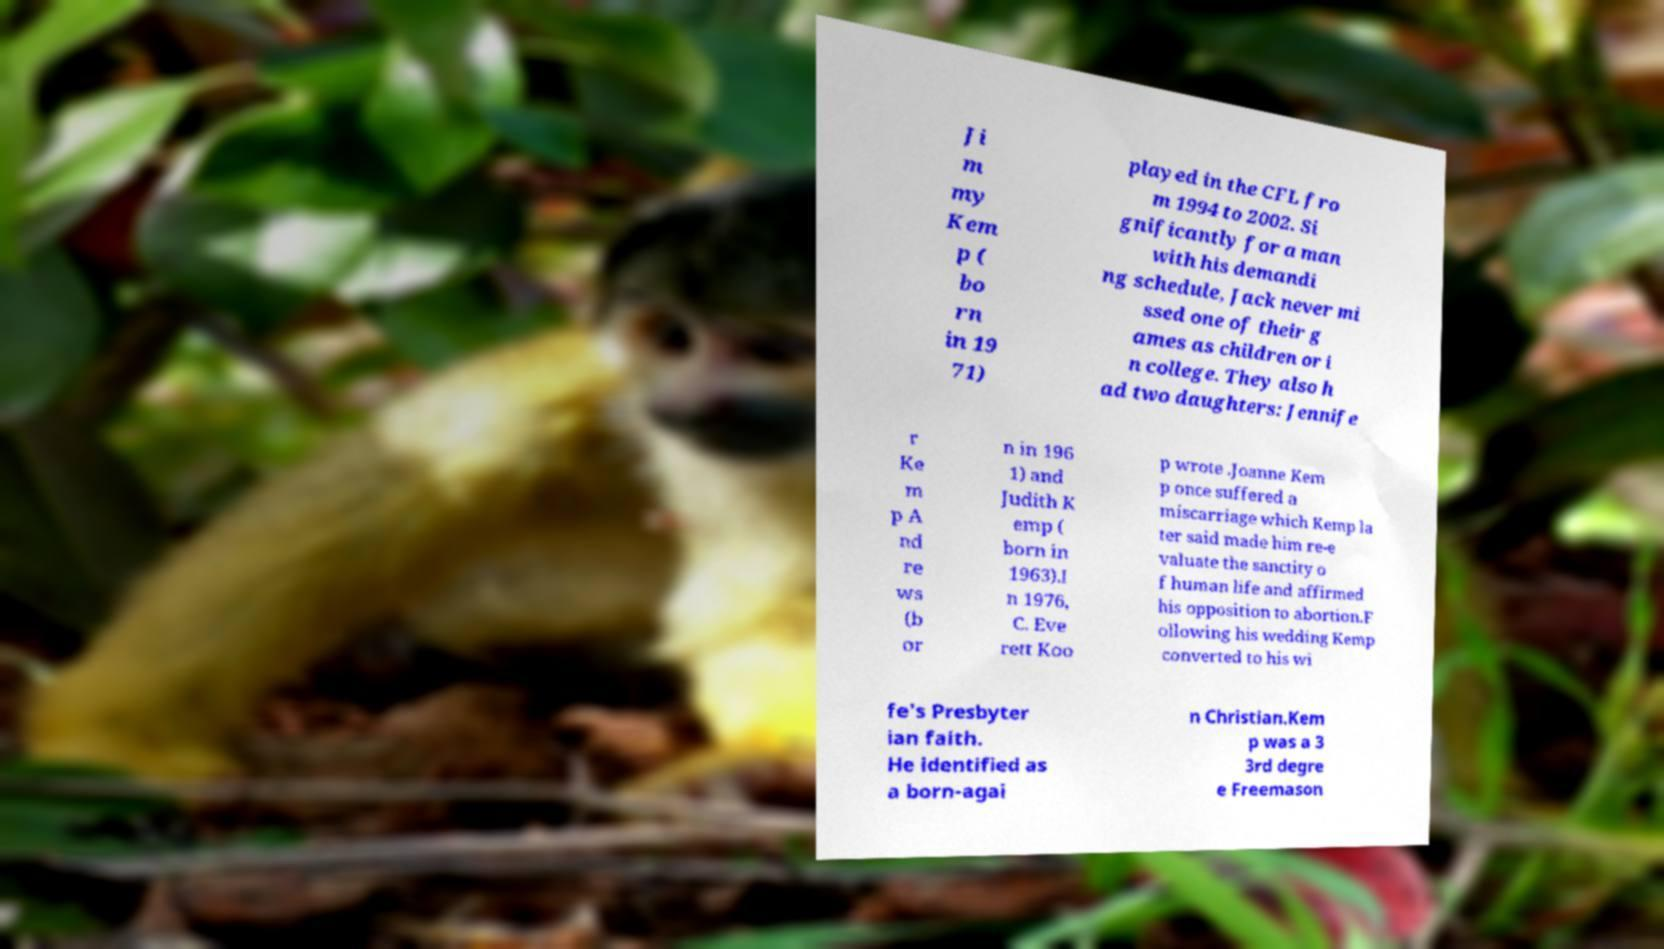Please identify and transcribe the text found in this image. Ji m my Kem p ( bo rn in 19 71) played in the CFL fro m 1994 to 2002. Si gnificantly for a man with his demandi ng schedule, Jack never mi ssed one of their g ames as children or i n college. They also h ad two daughters: Jennife r Ke m p A nd re ws (b or n in 196 1) and Judith K emp ( born in 1963).I n 1976, C. Eve rett Koo p wrote .Joanne Kem p once suffered a miscarriage which Kemp la ter said made him re-e valuate the sanctity o f human life and affirmed his opposition to abortion.F ollowing his wedding Kemp converted to his wi fe's Presbyter ian faith. He identified as a born-agai n Christian.Kem p was a 3 3rd degre e Freemason 